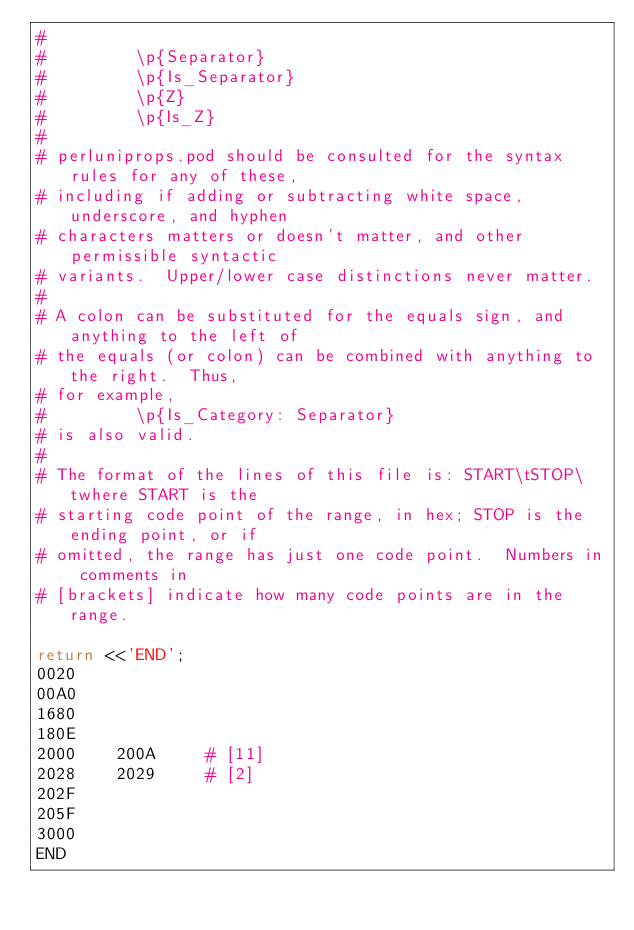Convert code to text. <code><loc_0><loc_0><loc_500><loc_500><_Perl_># 
#         \p{Separator}
#         \p{Is_Separator}
#         \p{Z}
#         \p{Is_Z}
# 
# perluniprops.pod should be consulted for the syntax rules for any of these,
# including if adding or subtracting white space, underscore, and hyphen
# characters matters or doesn't matter, and other permissible syntactic
# variants.  Upper/lower case distinctions never matter.
# 
# A colon can be substituted for the equals sign, and anything to the left of
# the equals (or colon) can be combined with anything to the right.  Thus,
# for example,
#         \p{Is_Category: Separator}
# is also valid.
# 
# The format of the lines of this file is: START\tSTOP\twhere START is the
# starting code point of the range, in hex; STOP is the ending point, or if
# omitted, the range has just one code point.  Numbers in comments in
# [brackets] indicate how many code points are in the range.

return <<'END';
0020		
00A0		
1680		
180E		
2000	200A	 # [11]
2028	2029	 # [2]
202F		
205F		
3000		
END
</code> 